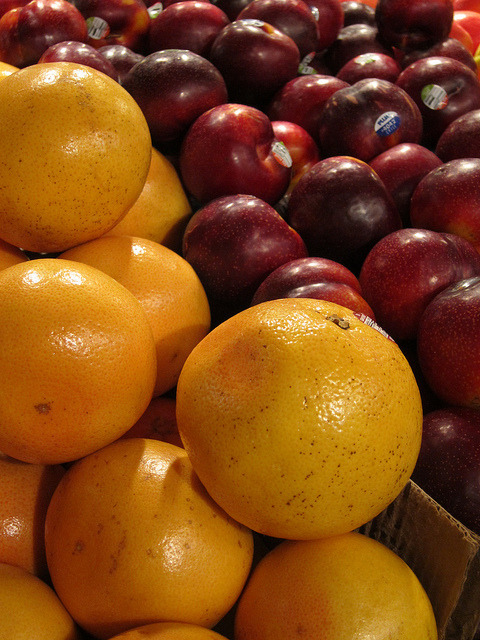Can one fruit be sliced and juiced? Certainly, the oranges displayed are excellent for both slicing and juicing thanks to their size and juiciness. 